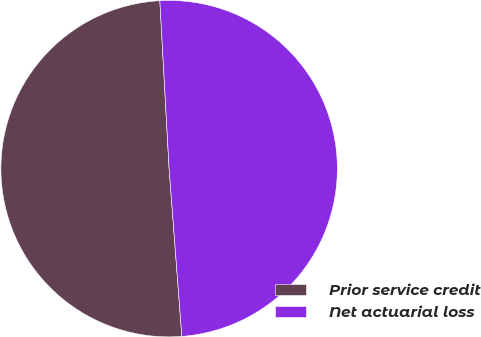<chart> <loc_0><loc_0><loc_500><loc_500><pie_chart><fcel>Prior service credit<fcel>Net actuarial loss<nl><fcel>50.33%<fcel>49.67%<nl></chart> 